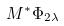Convert formula to latex. <formula><loc_0><loc_0><loc_500><loc_500>M ^ { * } \Phi _ { 2 \lambda }</formula> 